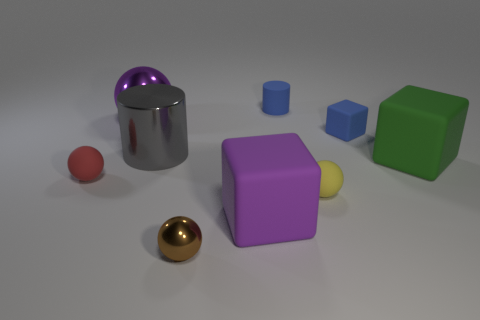Subtract all blocks. How many objects are left? 6 Subtract all small gray cylinders. Subtract all yellow matte objects. How many objects are left? 8 Add 5 tiny blue rubber cylinders. How many tiny blue rubber cylinders are left? 6 Add 2 red cubes. How many red cubes exist? 2 Subtract 0 cyan cylinders. How many objects are left? 9 